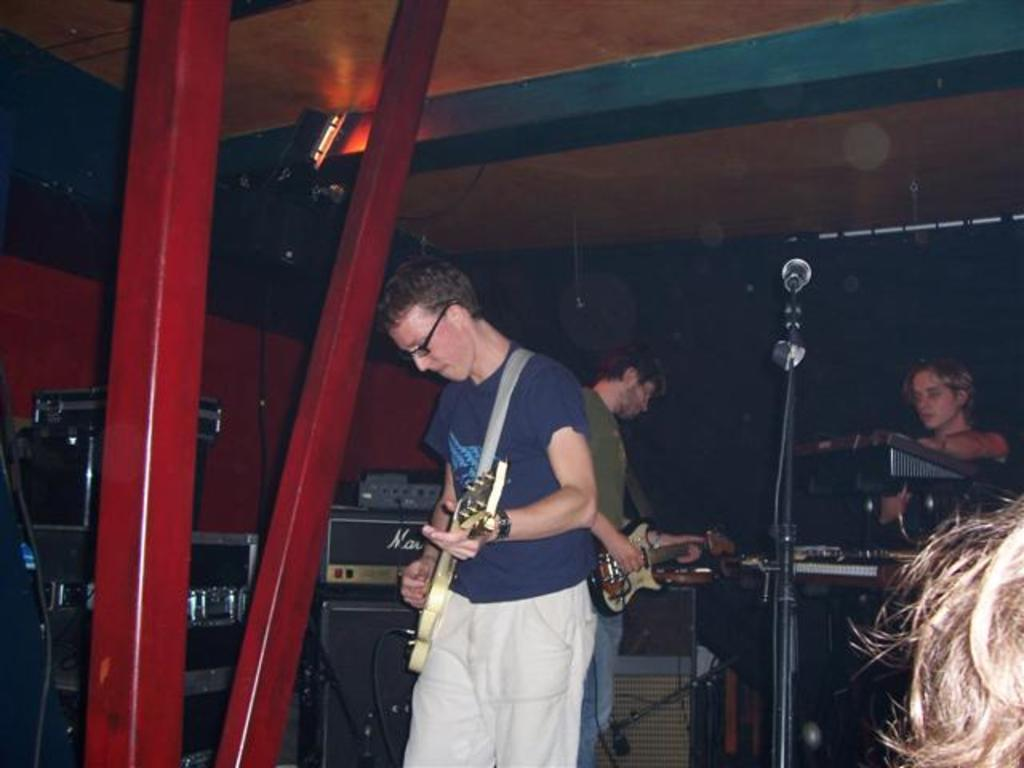What is the main activity of the group of persons in the image? The group of persons in the image are playing musical instruments. What can be seen in the background of the image? There are sound boxes and microphones in the background of the image. How many cows are present in the image? There are no cows present in the image. What year is depicted in the image? The image does not depict a specific year; it is a snapshot of a moment in time. 